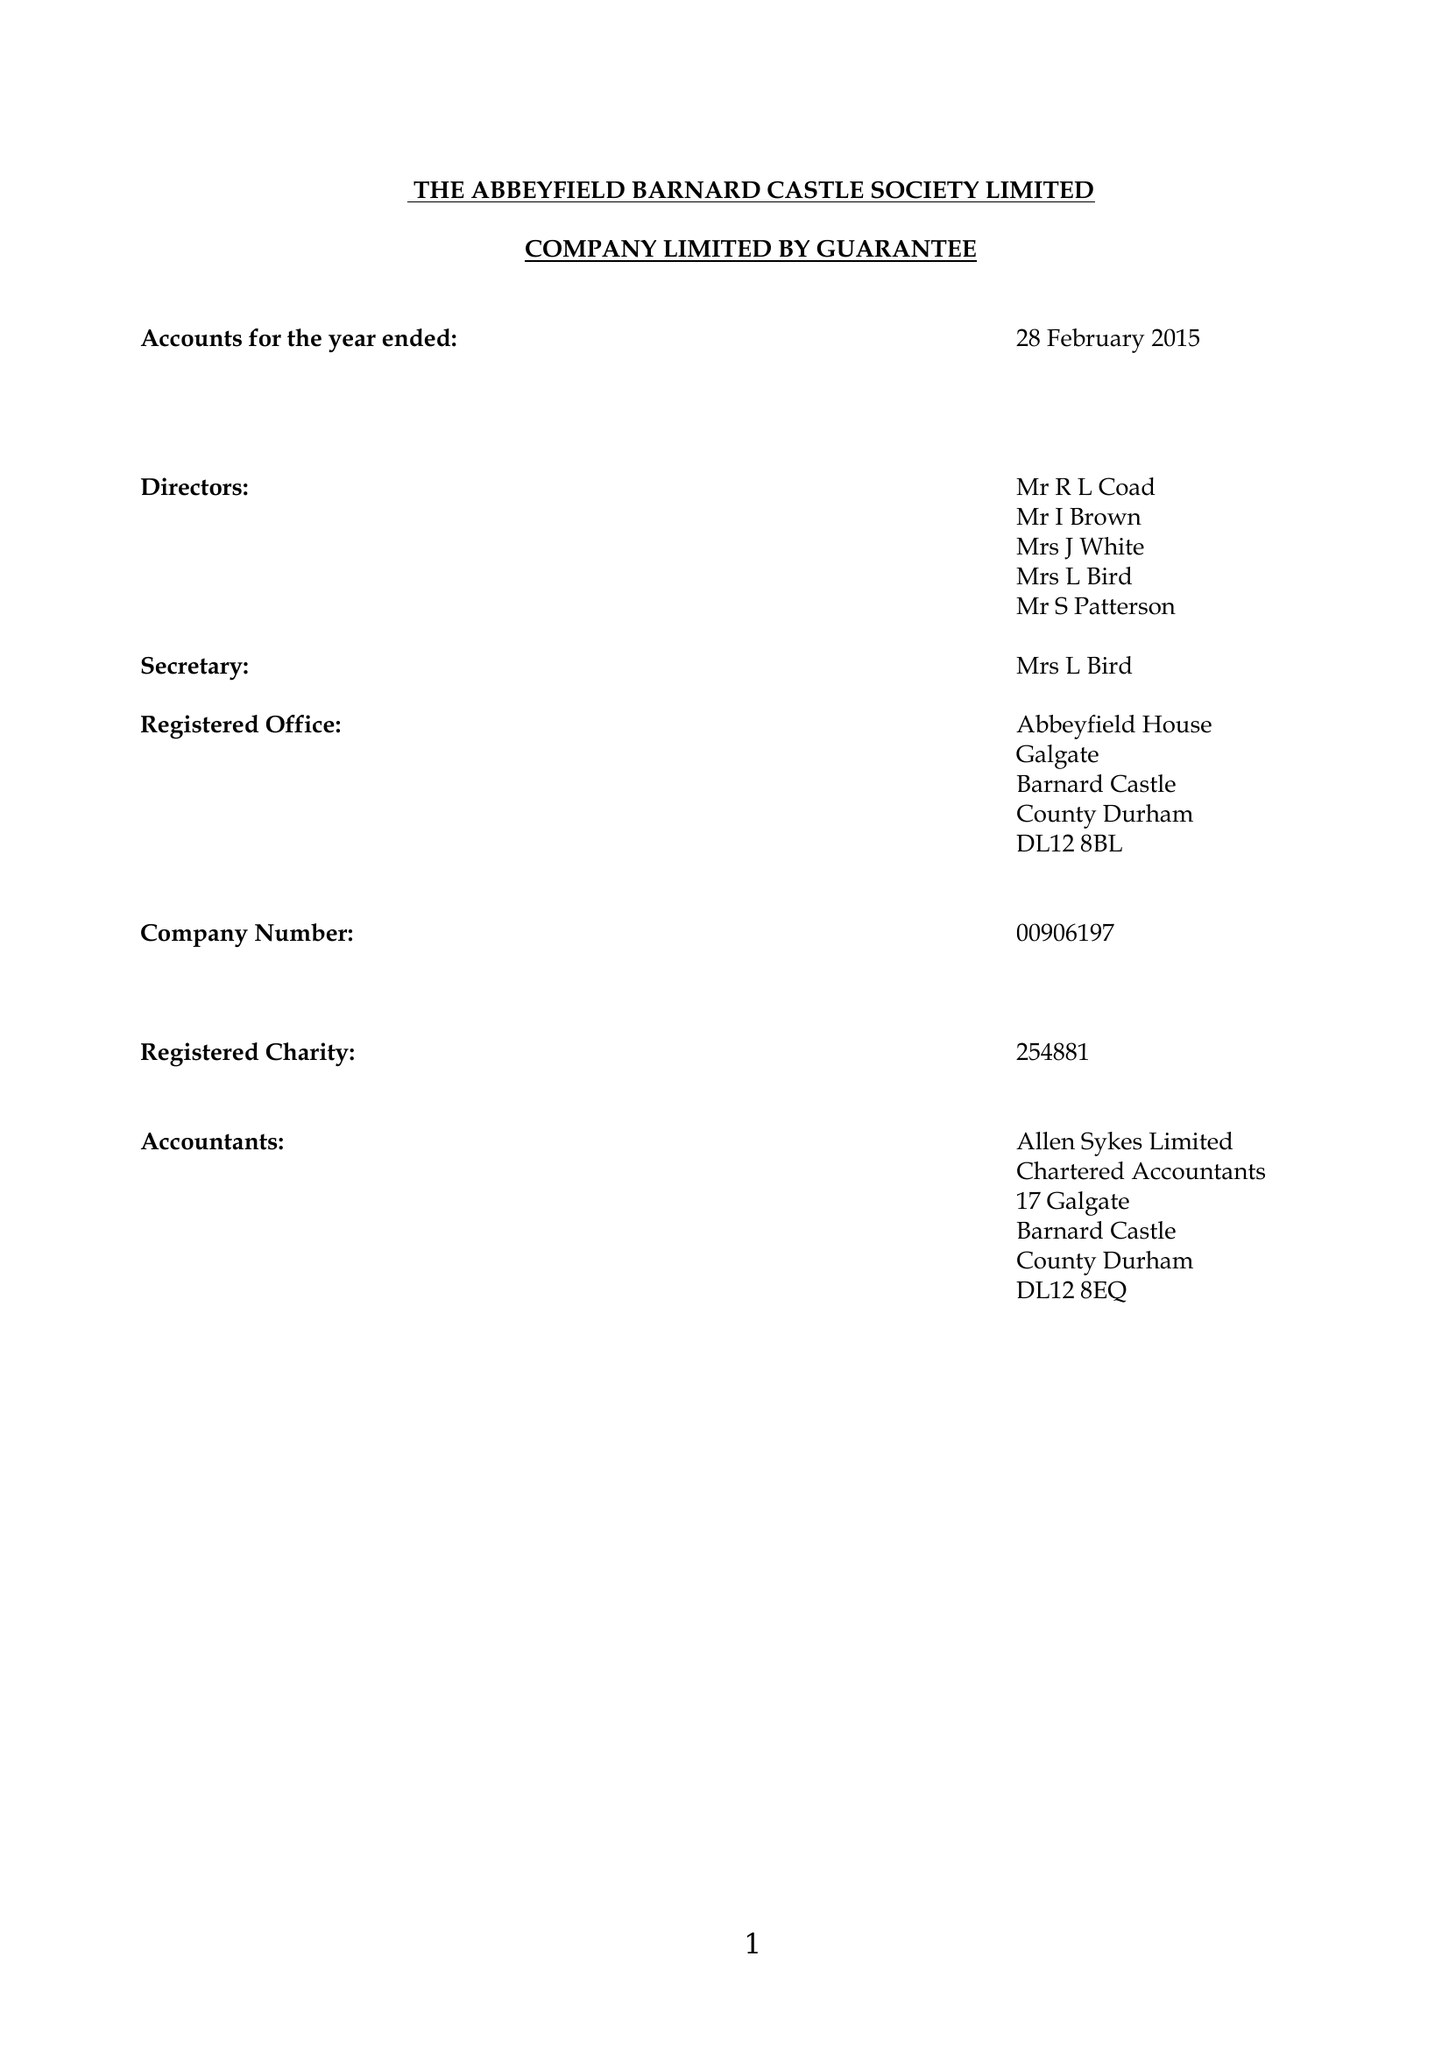What is the value for the charity_name?
Answer the question using a single word or phrase. The Abbeyfield Barnard Castle Society Ltd. 